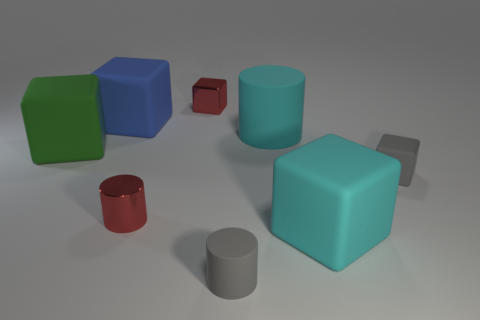There is a large cyan object that is in front of the red metallic cylinder; what is its material?
Make the answer very short. Rubber. Are there more small things than objects?
Offer a very short reply. No. What number of things are either metal objects behind the tiny red metal cylinder or tiny gray cubes?
Offer a terse response. 2. There is a small cube that is left of the big cylinder; how many tiny gray cubes are behind it?
Ensure brevity in your answer.  0. What is the size of the thing that is on the right side of the large matte block that is in front of the small gray thing that is to the right of the small gray rubber cylinder?
Make the answer very short. Small. There is a large matte object in front of the large green cube; is it the same color as the big matte cylinder?
Ensure brevity in your answer.  Yes. The gray thing that is the same shape as the green rubber object is what size?
Ensure brevity in your answer.  Small. What number of things are either big matte things to the left of the tiny rubber cylinder or things behind the cyan matte block?
Give a very brief answer. 6. There is a tiny metallic thing that is in front of the matte cylinder behind the big cyan block; what is its shape?
Offer a very short reply. Cylinder. Is there anything else of the same color as the small metal cube?
Ensure brevity in your answer.  Yes. 